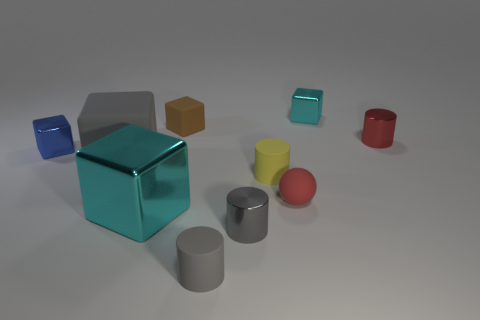Can you describe the color composition in this image? The image displays a variety of colors with objects ranging from a shiny turquoise cube, blue and red cylinders, yellow and orange cubes, to gray cylinders and a red sphere. The scene's color palette consists of both primary colors like red and blue and secondary colors like orange and a mix of earth tones and metallic shades for the other objects. 